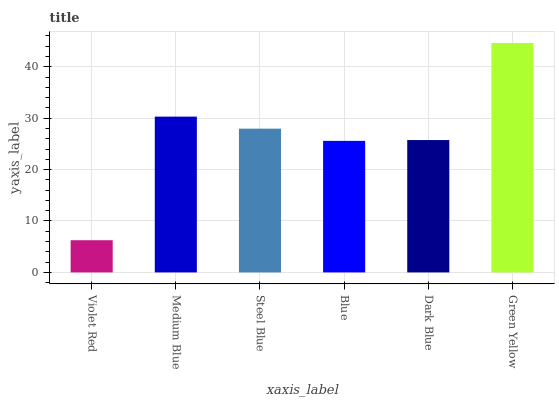Is Medium Blue the minimum?
Answer yes or no. No. Is Medium Blue the maximum?
Answer yes or no. No. Is Medium Blue greater than Violet Red?
Answer yes or no. Yes. Is Violet Red less than Medium Blue?
Answer yes or no. Yes. Is Violet Red greater than Medium Blue?
Answer yes or no. No. Is Medium Blue less than Violet Red?
Answer yes or no. No. Is Steel Blue the high median?
Answer yes or no. Yes. Is Dark Blue the low median?
Answer yes or no. Yes. Is Medium Blue the high median?
Answer yes or no. No. Is Steel Blue the low median?
Answer yes or no. No. 